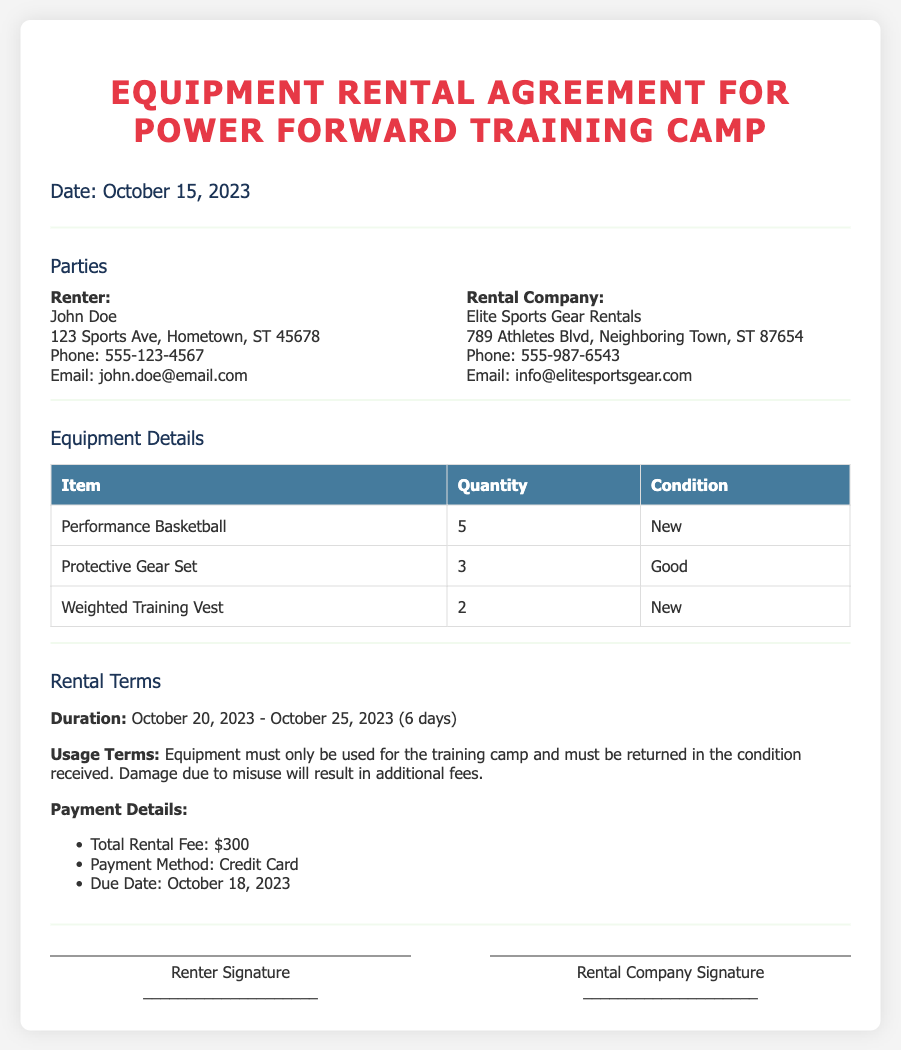What is the rental duration? The rental duration is specified in the document as the period from October 20, 2023, to October 25, 2023.
Answer: October 20, 2023 - October 25, 2023 Who is the renter? The renter's name is listed in the document as John Doe.
Answer: John Doe What is the total rental fee? The total rental fee is stated in the document as $300.
Answer: $300 What condition is the protective gear set in? The document specifies the condition of the protective gear set as "Good."
Answer: Good What is the due date for payment? The due date for payment is mentioned in the document as October 18, 2023.
Answer: October 18, 2023 What equipment is being rented? The document lists specific items being rented, including Performance Basketballs, Protective Gear Set, and Weighted Training Vest.
Answer: Performance Basketball, Protective Gear Set, Weighted Training Vest What happens if the equipment is damaged due to misuse? The rental agreement states that damage due to misuse will result in additional fees.
Answer: Additional fees What company is providing the rental equipment? The document identifies the rental company as Elite Sports Gear Rentals.
Answer: Elite Sports Gear Rentals 